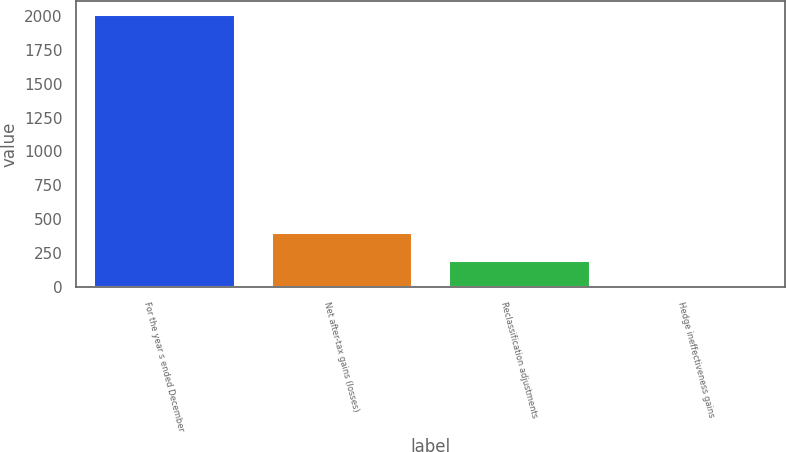Convert chart. <chart><loc_0><loc_0><loc_500><loc_500><bar_chart><fcel>For the year s ended December<fcel>Net after-tax gains (losses)<fcel>Reclassification adjustments<fcel>Hedge ineffectiveness gains<nl><fcel>2011<fcel>403.8<fcel>202.9<fcel>2<nl></chart> 